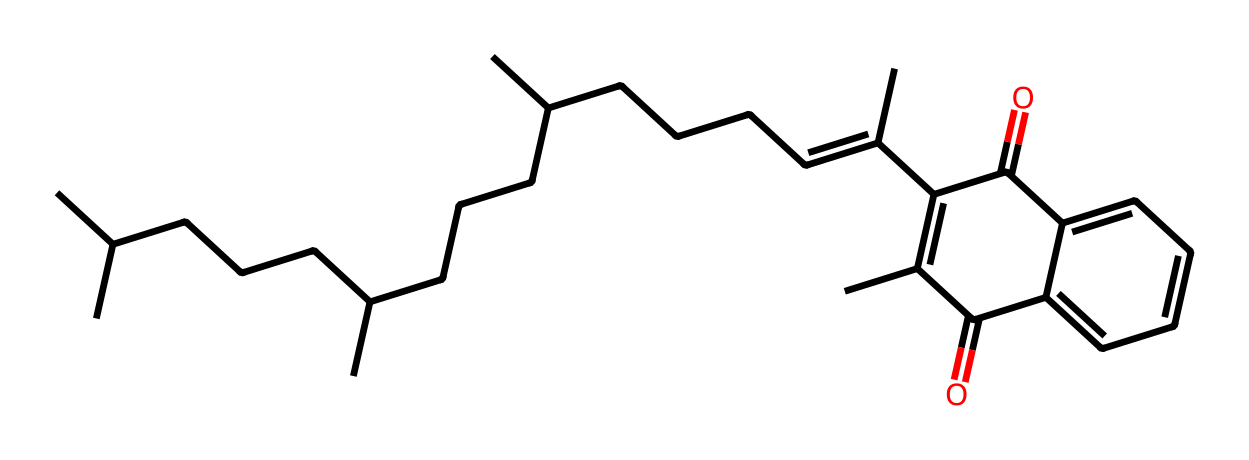What is the general name of the molecule represented by this SMILES? The SMILES representation shows a complex organic structure that includes a long carbon chain and multiple functional groups, characteristic of vitamin K, particularly K1 or phylloquinone.
Answer: vitamin K How many carbon atoms are present in this molecule? By analyzing the structure represented in the SMILES, we can count the carbon atoms indicated by 'C' and deduce the number of carbon atoms present, which totals 30 carbon atoms.
Answer: 30 What type of functional groups are present in this vitamin? The structure features two ketone groups (indicated by the C=O) present in its structure, which is typical for vitamin K, contributing to its biological function and properties.
Answer: ketone How does the conjugated system in this molecule influence its behavior? The presence of conjugated double bonds within the molecule allows for resonance delocalization, which helps vitamin K stabilize free radicals and is crucial for its function in blood clotting.
Answer: resonance Which biosynthetic process is this vitamin particularly crucial for? Vitamin K plays a key role in the gamma-carboxylation of certain proteins, which is vital in the synthesis of clotting factors necessary for coagulation in the blood.
Answer: blood clotting What is a primary reason vitamin K is important for health? Vitamin K's primary importance lies in its function in blood coagulation, which prevents excessive bleeding by helping in the clotting factor production in the liver.
Answer: coagulation In which type of food is vitamin K most abundantly found? Leafy green vegetables are well known to be the richest sources of vitamin K, particularly in forms such as phylloquinone.
Answer: leafy greens 